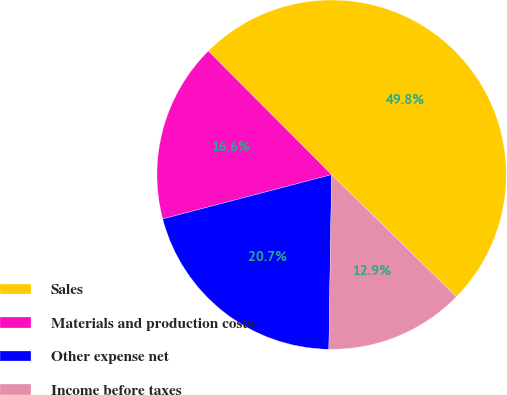<chart> <loc_0><loc_0><loc_500><loc_500><pie_chart><fcel>Sales<fcel>Materials and production costs<fcel>Other expense net<fcel>Income before taxes<nl><fcel>49.79%<fcel>16.61%<fcel>20.67%<fcel>12.93%<nl></chart> 